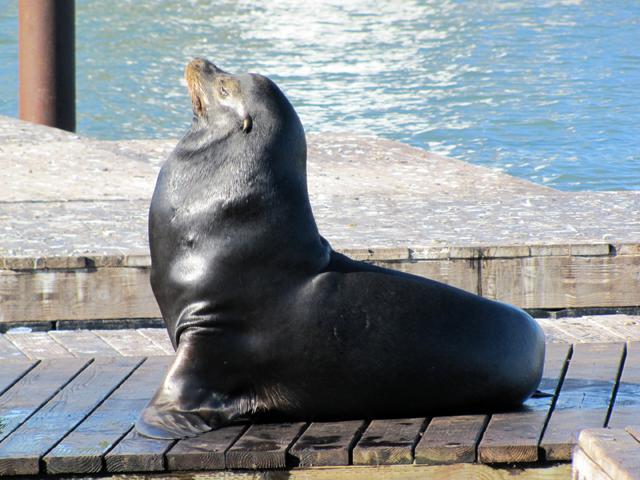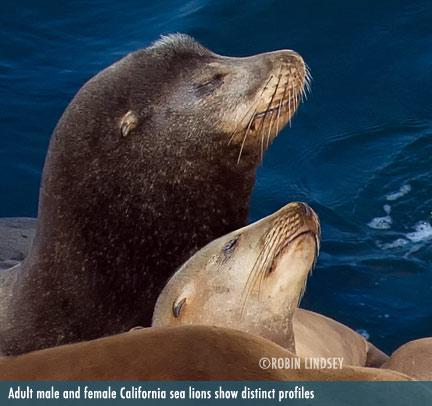The first image is the image on the left, the second image is the image on the right. Evaluate the accuracy of this statement regarding the images: "Each image shows a seal performing in a show, and one image shows a seal balancing on a stone ledge with at least part of its body held in the air.". Is it true? Answer yes or no. No. The first image is the image on the left, the second image is the image on the right. Considering the images on both sides, is "there are seals in a pool encased in glass fencing" valid? Answer yes or no. No. 